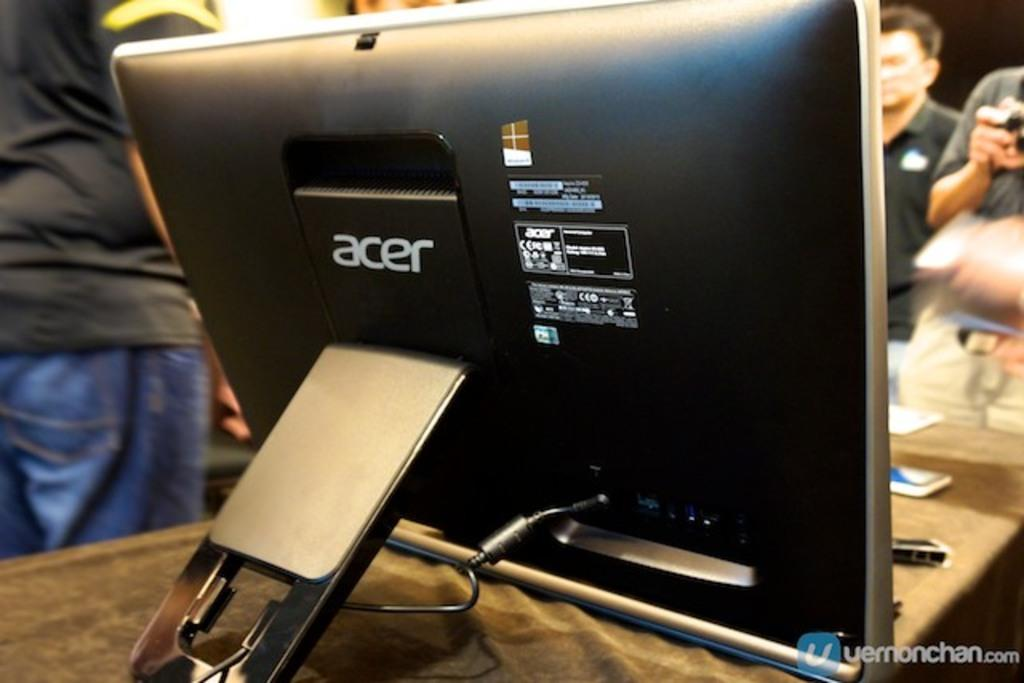What is the main object visible on the table in the image? There is a monitor on the table in the image. What else can be seen on the table besides the monitor? There are other objects on the table, but their specific details are not mentioned in the provided facts. Can you describe the people standing in front of the table? The provided facts do not give any information about the people standing in front of the table, so we cannot describe them. What type of scissors are being used to express an opinion about waste in the image? There is no mention of scissors, opinions, or waste in the image, so this question cannot be answered based on the provided facts. 